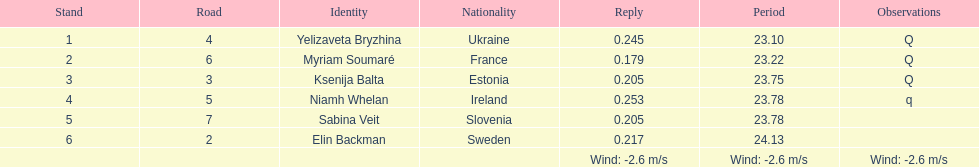How long did it take elin backman to finish the race? 24.13. 